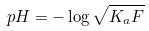Convert formula to latex. <formula><loc_0><loc_0><loc_500><loc_500>p H = - \log \sqrt { K _ { a } F }</formula> 